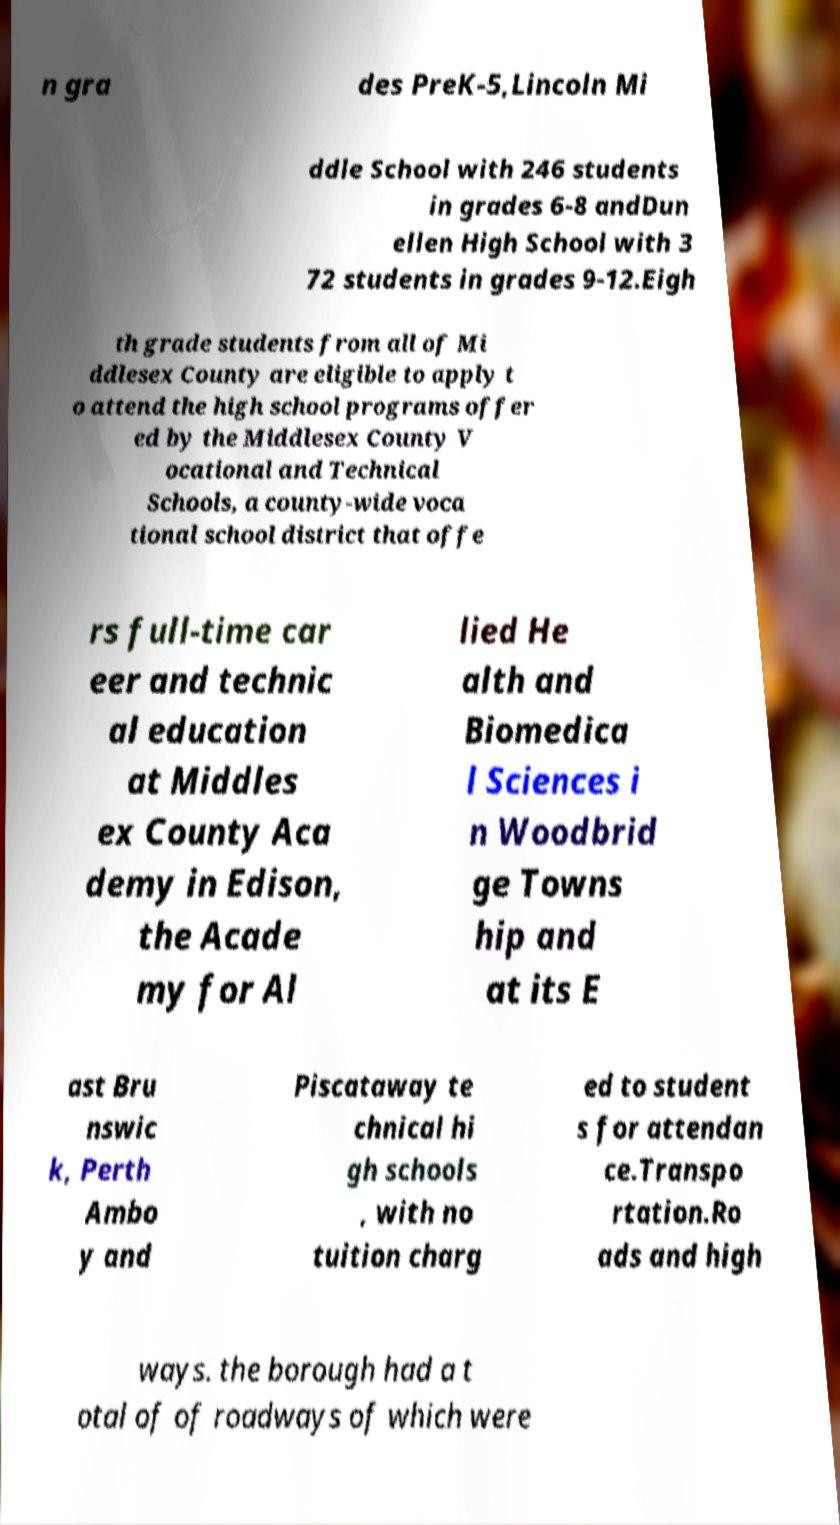There's text embedded in this image that I need extracted. Can you transcribe it verbatim? n gra des PreK-5,Lincoln Mi ddle School with 246 students in grades 6-8 andDun ellen High School with 3 72 students in grades 9-12.Eigh th grade students from all of Mi ddlesex County are eligible to apply t o attend the high school programs offer ed by the Middlesex County V ocational and Technical Schools, a county-wide voca tional school district that offe rs full-time car eer and technic al education at Middles ex County Aca demy in Edison, the Acade my for Al lied He alth and Biomedica l Sciences i n Woodbrid ge Towns hip and at its E ast Bru nswic k, Perth Ambo y and Piscataway te chnical hi gh schools , with no tuition charg ed to student s for attendan ce.Transpo rtation.Ro ads and high ways. the borough had a t otal of of roadways of which were 